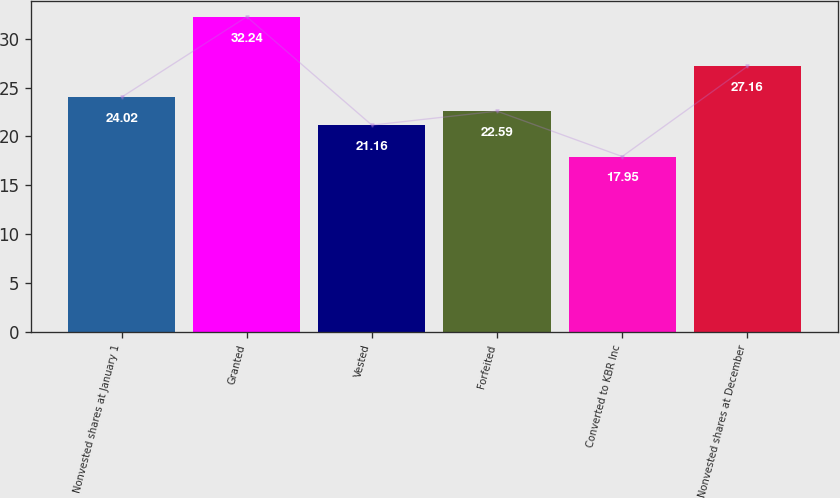Convert chart. <chart><loc_0><loc_0><loc_500><loc_500><bar_chart><fcel>Nonvested shares at January 1<fcel>Granted<fcel>Vested<fcel>Forfeited<fcel>Converted to KBR Inc<fcel>Nonvested shares at December<nl><fcel>24.02<fcel>32.24<fcel>21.16<fcel>22.59<fcel>17.95<fcel>27.16<nl></chart> 